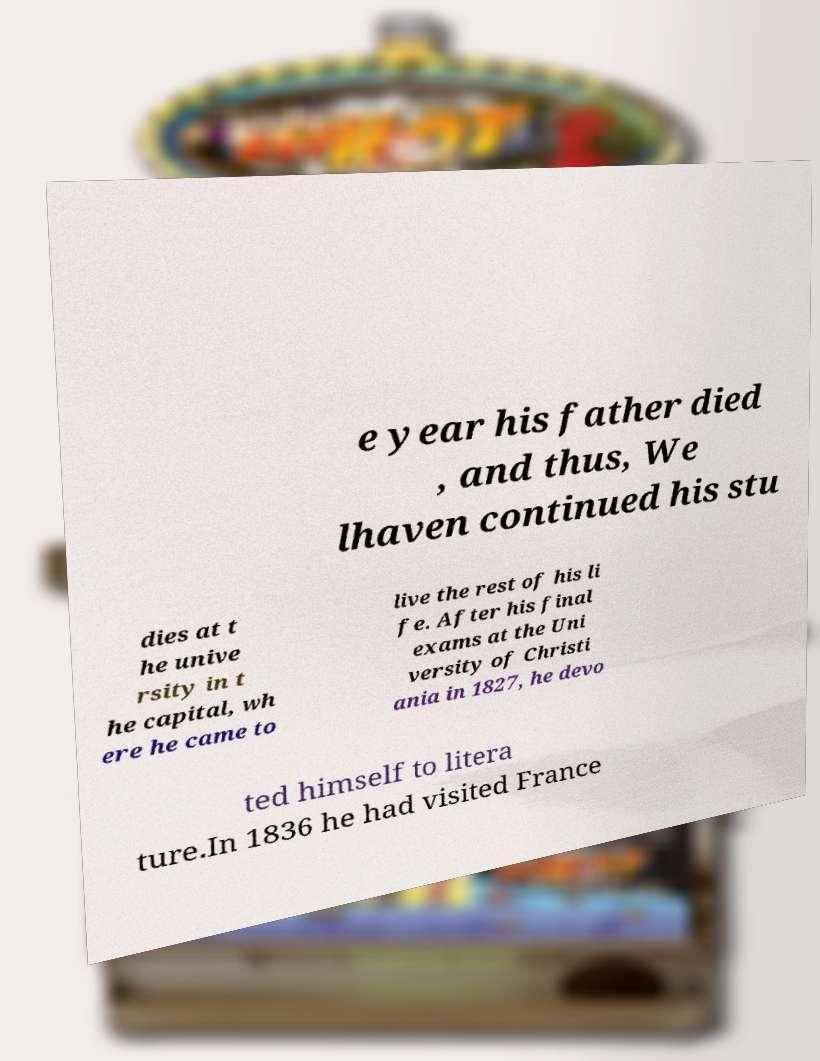Please identify and transcribe the text found in this image. e year his father died , and thus, We lhaven continued his stu dies at t he unive rsity in t he capital, wh ere he came to live the rest of his li fe. After his final exams at the Uni versity of Christi ania in 1827, he devo ted himself to litera ture.In 1836 he had visited France 